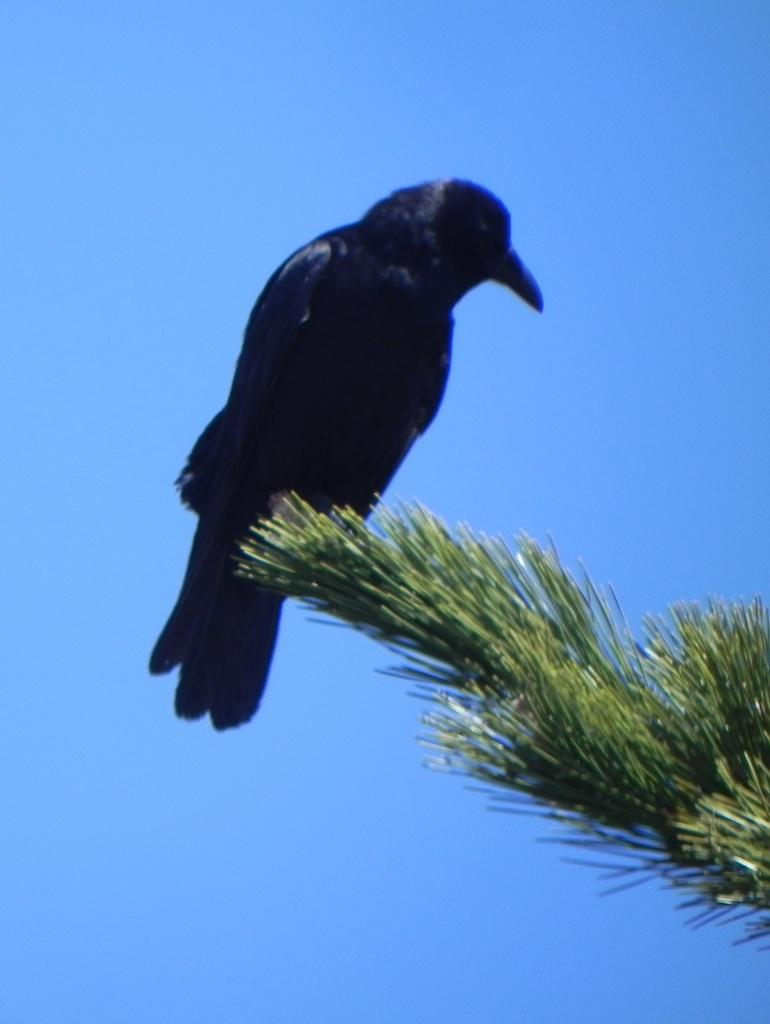What type of bird is in the image? There is a crow in the image. Where is the crow located? The crow is on a tree. What can be seen in the background of the image? There is a sky visible in the background of the image. How many cows are present in the image? There are no cows present in the image; it features a crow on a tree. What type of thing is the crow holding in the image? The crow is not holding anything in the image; it is simply perched on a tree. 